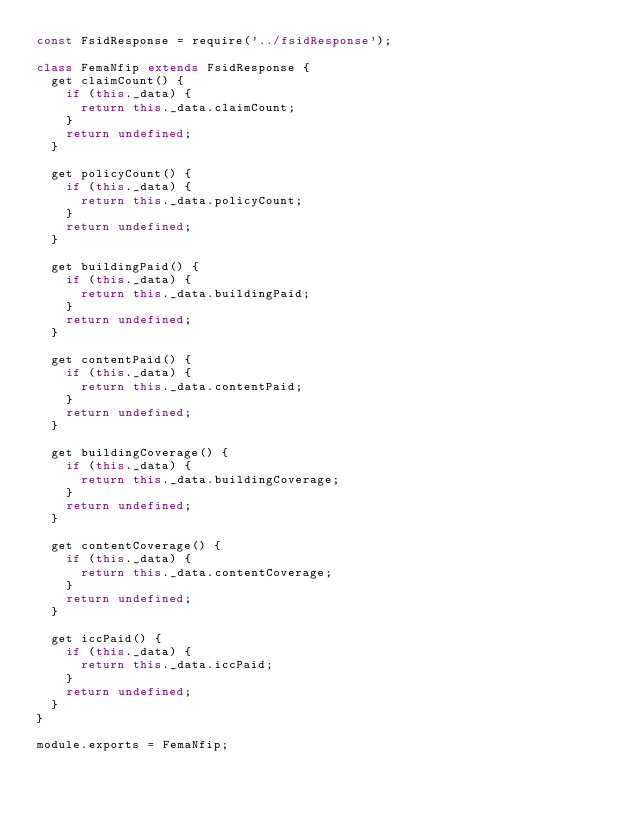Convert code to text. <code><loc_0><loc_0><loc_500><loc_500><_JavaScript_>const FsidResponse = require('../fsidResponse');

class FemaNfip extends FsidResponse {
  get claimCount() {
    if (this._data) {
      return this._data.claimCount;
    }
    return undefined;
  }

  get policyCount() {
    if (this._data) {
      return this._data.policyCount;
    }
    return undefined;
  }

  get buildingPaid() {
    if (this._data) {
      return this._data.buildingPaid;
    }
    return undefined;
  }

  get contentPaid() {
    if (this._data) {
      return this._data.contentPaid;
    }
    return undefined;
  }

  get buildingCoverage() {
    if (this._data) {
      return this._data.buildingCoverage;
    }
    return undefined;
  }

  get contentCoverage() {
    if (this._data) {
      return this._data.contentCoverage;
    }
    return undefined;
  }

  get iccPaid() {
    if (this._data) {
      return this._data.iccPaid;
    }
    return undefined;
  }
}

module.exports = FemaNfip;
</code> 